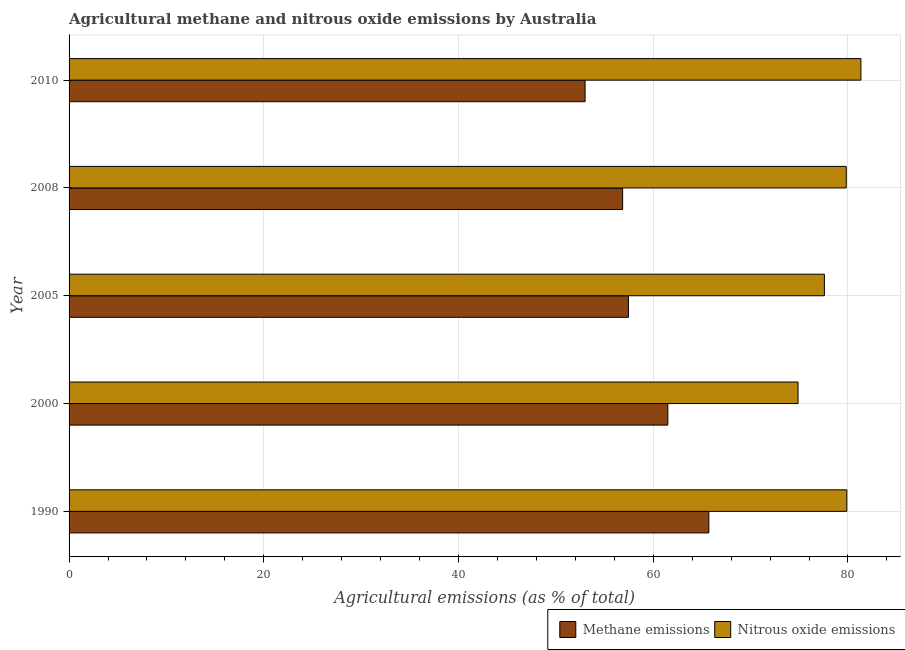How many groups of bars are there?
Ensure brevity in your answer.  5. Are the number of bars per tick equal to the number of legend labels?
Your answer should be compact. Yes. Are the number of bars on each tick of the Y-axis equal?
Keep it short and to the point. Yes. What is the label of the 4th group of bars from the top?
Offer a very short reply. 2000. In how many cases, is the number of bars for a given year not equal to the number of legend labels?
Offer a terse response. 0. What is the amount of nitrous oxide emissions in 2010?
Make the answer very short. 81.33. Across all years, what is the maximum amount of nitrous oxide emissions?
Ensure brevity in your answer.  81.33. Across all years, what is the minimum amount of methane emissions?
Keep it short and to the point. 53. In which year was the amount of nitrous oxide emissions maximum?
Ensure brevity in your answer.  2010. In which year was the amount of methane emissions minimum?
Provide a short and direct response. 2010. What is the total amount of methane emissions in the graph?
Give a very brief answer. 294.51. What is the difference between the amount of methane emissions in 1990 and that in 2008?
Make the answer very short. 8.86. What is the difference between the amount of nitrous oxide emissions in 2005 and the amount of methane emissions in 2008?
Your answer should be compact. 20.72. What is the average amount of methane emissions per year?
Offer a terse response. 58.9. In the year 2008, what is the difference between the amount of methane emissions and amount of nitrous oxide emissions?
Your response must be concise. -22.96. In how many years, is the amount of nitrous oxide emissions greater than 12 %?
Offer a terse response. 5. What is the ratio of the amount of methane emissions in 2005 to that in 2010?
Make the answer very short. 1.08. What is the difference between the highest and the second highest amount of nitrous oxide emissions?
Your answer should be compact. 1.45. What is the difference between the highest and the lowest amount of nitrous oxide emissions?
Ensure brevity in your answer.  6.46. What does the 1st bar from the top in 2005 represents?
Provide a short and direct response. Nitrous oxide emissions. What does the 2nd bar from the bottom in 2005 represents?
Provide a short and direct response. Nitrous oxide emissions. How many bars are there?
Keep it short and to the point. 10. How many years are there in the graph?
Your response must be concise. 5. Does the graph contain grids?
Provide a short and direct response. Yes. Where does the legend appear in the graph?
Provide a short and direct response. Bottom right. How many legend labels are there?
Offer a terse response. 2. What is the title of the graph?
Offer a very short reply. Agricultural methane and nitrous oxide emissions by Australia. Does "Rural" appear as one of the legend labels in the graph?
Offer a very short reply. No. What is the label or title of the X-axis?
Ensure brevity in your answer.  Agricultural emissions (as % of total). What is the label or title of the Y-axis?
Give a very brief answer. Year. What is the Agricultural emissions (as % of total) of Methane emissions in 1990?
Give a very brief answer. 65.71. What is the Agricultural emissions (as % of total) in Nitrous oxide emissions in 1990?
Ensure brevity in your answer.  79.88. What is the Agricultural emissions (as % of total) in Methane emissions in 2000?
Provide a succinct answer. 61.5. What is the Agricultural emissions (as % of total) in Nitrous oxide emissions in 2000?
Offer a terse response. 74.87. What is the Agricultural emissions (as % of total) of Methane emissions in 2005?
Offer a very short reply. 57.45. What is the Agricultural emissions (as % of total) of Nitrous oxide emissions in 2005?
Offer a very short reply. 77.58. What is the Agricultural emissions (as % of total) in Methane emissions in 2008?
Your answer should be very brief. 56.85. What is the Agricultural emissions (as % of total) in Nitrous oxide emissions in 2008?
Ensure brevity in your answer.  79.82. What is the Agricultural emissions (as % of total) in Methane emissions in 2010?
Your answer should be very brief. 53. What is the Agricultural emissions (as % of total) of Nitrous oxide emissions in 2010?
Make the answer very short. 81.33. Across all years, what is the maximum Agricultural emissions (as % of total) in Methane emissions?
Make the answer very short. 65.71. Across all years, what is the maximum Agricultural emissions (as % of total) of Nitrous oxide emissions?
Offer a terse response. 81.33. Across all years, what is the minimum Agricultural emissions (as % of total) in Methane emissions?
Offer a very short reply. 53. Across all years, what is the minimum Agricultural emissions (as % of total) in Nitrous oxide emissions?
Your answer should be very brief. 74.87. What is the total Agricultural emissions (as % of total) in Methane emissions in the graph?
Your answer should be very brief. 294.51. What is the total Agricultural emissions (as % of total) of Nitrous oxide emissions in the graph?
Your answer should be compact. 393.48. What is the difference between the Agricultural emissions (as % of total) in Methane emissions in 1990 and that in 2000?
Give a very brief answer. 4.21. What is the difference between the Agricultural emissions (as % of total) of Nitrous oxide emissions in 1990 and that in 2000?
Offer a terse response. 5.01. What is the difference between the Agricultural emissions (as % of total) in Methane emissions in 1990 and that in 2005?
Provide a short and direct response. 8.26. What is the difference between the Agricultural emissions (as % of total) of Nitrous oxide emissions in 1990 and that in 2005?
Make the answer very short. 2.3. What is the difference between the Agricultural emissions (as % of total) of Methane emissions in 1990 and that in 2008?
Provide a short and direct response. 8.85. What is the difference between the Agricultural emissions (as % of total) in Nitrous oxide emissions in 1990 and that in 2008?
Give a very brief answer. 0.06. What is the difference between the Agricultural emissions (as % of total) of Methane emissions in 1990 and that in 2010?
Make the answer very short. 12.71. What is the difference between the Agricultural emissions (as % of total) in Nitrous oxide emissions in 1990 and that in 2010?
Your answer should be very brief. -1.45. What is the difference between the Agricultural emissions (as % of total) in Methane emissions in 2000 and that in 2005?
Provide a short and direct response. 4.04. What is the difference between the Agricultural emissions (as % of total) in Nitrous oxide emissions in 2000 and that in 2005?
Your answer should be very brief. -2.71. What is the difference between the Agricultural emissions (as % of total) of Methane emissions in 2000 and that in 2008?
Your answer should be very brief. 4.64. What is the difference between the Agricultural emissions (as % of total) of Nitrous oxide emissions in 2000 and that in 2008?
Keep it short and to the point. -4.95. What is the difference between the Agricultural emissions (as % of total) in Methane emissions in 2000 and that in 2010?
Make the answer very short. 8.5. What is the difference between the Agricultural emissions (as % of total) in Nitrous oxide emissions in 2000 and that in 2010?
Offer a very short reply. -6.46. What is the difference between the Agricultural emissions (as % of total) in Methane emissions in 2005 and that in 2008?
Your answer should be compact. 0.6. What is the difference between the Agricultural emissions (as % of total) of Nitrous oxide emissions in 2005 and that in 2008?
Your answer should be compact. -2.24. What is the difference between the Agricultural emissions (as % of total) in Methane emissions in 2005 and that in 2010?
Ensure brevity in your answer.  4.45. What is the difference between the Agricultural emissions (as % of total) of Nitrous oxide emissions in 2005 and that in 2010?
Give a very brief answer. -3.75. What is the difference between the Agricultural emissions (as % of total) in Methane emissions in 2008 and that in 2010?
Give a very brief answer. 3.86. What is the difference between the Agricultural emissions (as % of total) in Nitrous oxide emissions in 2008 and that in 2010?
Your answer should be very brief. -1.51. What is the difference between the Agricultural emissions (as % of total) in Methane emissions in 1990 and the Agricultural emissions (as % of total) in Nitrous oxide emissions in 2000?
Give a very brief answer. -9.16. What is the difference between the Agricultural emissions (as % of total) in Methane emissions in 1990 and the Agricultural emissions (as % of total) in Nitrous oxide emissions in 2005?
Your answer should be compact. -11.87. What is the difference between the Agricultural emissions (as % of total) in Methane emissions in 1990 and the Agricultural emissions (as % of total) in Nitrous oxide emissions in 2008?
Provide a succinct answer. -14.11. What is the difference between the Agricultural emissions (as % of total) in Methane emissions in 1990 and the Agricultural emissions (as % of total) in Nitrous oxide emissions in 2010?
Offer a very short reply. -15.62. What is the difference between the Agricultural emissions (as % of total) in Methane emissions in 2000 and the Agricultural emissions (as % of total) in Nitrous oxide emissions in 2005?
Your answer should be very brief. -16.08. What is the difference between the Agricultural emissions (as % of total) of Methane emissions in 2000 and the Agricultural emissions (as % of total) of Nitrous oxide emissions in 2008?
Provide a succinct answer. -18.32. What is the difference between the Agricultural emissions (as % of total) of Methane emissions in 2000 and the Agricultural emissions (as % of total) of Nitrous oxide emissions in 2010?
Make the answer very short. -19.83. What is the difference between the Agricultural emissions (as % of total) of Methane emissions in 2005 and the Agricultural emissions (as % of total) of Nitrous oxide emissions in 2008?
Offer a terse response. -22.37. What is the difference between the Agricultural emissions (as % of total) of Methane emissions in 2005 and the Agricultural emissions (as % of total) of Nitrous oxide emissions in 2010?
Provide a succinct answer. -23.88. What is the difference between the Agricultural emissions (as % of total) in Methane emissions in 2008 and the Agricultural emissions (as % of total) in Nitrous oxide emissions in 2010?
Your response must be concise. -24.47. What is the average Agricultural emissions (as % of total) of Methane emissions per year?
Ensure brevity in your answer.  58.9. What is the average Agricultural emissions (as % of total) of Nitrous oxide emissions per year?
Provide a succinct answer. 78.7. In the year 1990, what is the difference between the Agricultural emissions (as % of total) of Methane emissions and Agricultural emissions (as % of total) of Nitrous oxide emissions?
Give a very brief answer. -14.17. In the year 2000, what is the difference between the Agricultural emissions (as % of total) in Methane emissions and Agricultural emissions (as % of total) in Nitrous oxide emissions?
Offer a very short reply. -13.38. In the year 2005, what is the difference between the Agricultural emissions (as % of total) of Methane emissions and Agricultural emissions (as % of total) of Nitrous oxide emissions?
Offer a very short reply. -20.13. In the year 2008, what is the difference between the Agricultural emissions (as % of total) of Methane emissions and Agricultural emissions (as % of total) of Nitrous oxide emissions?
Give a very brief answer. -22.96. In the year 2010, what is the difference between the Agricultural emissions (as % of total) of Methane emissions and Agricultural emissions (as % of total) of Nitrous oxide emissions?
Your response must be concise. -28.33. What is the ratio of the Agricultural emissions (as % of total) in Methane emissions in 1990 to that in 2000?
Keep it short and to the point. 1.07. What is the ratio of the Agricultural emissions (as % of total) of Nitrous oxide emissions in 1990 to that in 2000?
Keep it short and to the point. 1.07. What is the ratio of the Agricultural emissions (as % of total) of Methane emissions in 1990 to that in 2005?
Your response must be concise. 1.14. What is the ratio of the Agricultural emissions (as % of total) in Nitrous oxide emissions in 1990 to that in 2005?
Your answer should be very brief. 1.03. What is the ratio of the Agricultural emissions (as % of total) of Methane emissions in 1990 to that in 2008?
Provide a short and direct response. 1.16. What is the ratio of the Agricultural emissions (as % of total) of Nitrous oxide emissions in 1990 to that in 2008?
Your answer should be very brief. 1. What is the ratio of the Agricultural emissions (as % of total) of Methane emissions in 1990 to that in 2010?
Your response must be concise. 1.24. What is the ratio of the Agricultural emissions (as % of total) of Nitrous oxide emissions in 1990 to that in 2010?
Provide a succinct answer. 0.98. What is the ratio of the Agricultural emissions (as % of total) in Methane emissions in 2000 to that in 2005?
Offer a very short reply. 1.07. What is the ratio of the Agricultural emissions (as % of total) of Nitrous oxide emissions in 2000 to that in 2005?
Your answer should be very brief. 0.97. What is the ratio of the Agricultural emissions (as % of total) in Methane emissions in 2000 to that in 2008?
Ensure brevity in your answer.  1.08. What is the ratio of the Agricultural emissions (as % of total) of Nitrous oxide emissions in 2000 to that in 2008?
Your answer should be very brief. 0.94. What is the ratio of the Agricultural emissions (as % of total) of Methane emissions in 2000 to that in 2010?
Your answer should be very brief. 1.16. What is the ratio of the Agricultural emissions (as % of total) of Nitrous oxide emissions in 2000 to that in 2010?
Provide a short and direct response. 0.92. What is the ratio of the Agricultural emissions (as % of total) in Methane emissions in 2005 to that in 2008?
Make the answer very short. 1.01. What is the ratio of the Agricultural emissions (as % of total) in Nitrous oxide emissions in 2005 to that in 2008?
Make the answer very short. 0.97. What is the ratio of the Agricultural emissions (as % of total) of Methane emissions in 2005 to that in 2010?
Make the answer very short. 1.08. What is the ratio of the Agricultural emissions (as % of total) of Nitrous oxide emissions in 2005 to that in 2010?
Provide a short and direct response. 0.95. What is the ratio of the Agricultural emissions (as % of total) in Methane emissions in 2008 to that in 2010?
Give a very brief answer. 1.07. What is the ratio of the Agricultural emissions (as % of total) of Nitrous oxide emissions in 2008 to that in 2010?
Offer a terse response. 0.98. What is the difference between the highest and the second highest Agricultural emissions (as % of total) in Methane emissions?
Offer a terse response. 4.21. What is the difference between the highest and the second highest Agricultural emissions (as % of total) of Nitrous oxide emissions?
Ensure brevity in your answer.  1.45. What is the difference between the highest and the lowest Agricultural emissions (as % of total) in Methane emissions?
Your answer should be very brief. 12.71. What is the difference between the highest and the lowest Agricultural emissions (as % of total) in Nitrous oxide emissions?
Give a very brief answer. 6.46. 